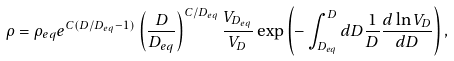Convert formula to latex. <formula><loc_0><loc_0><loc_500><loc_500>\rho = \rho _ { e q } e ^ { C ( D / D _ { e q } - 1 ) } \left ( \frac { D } { D _ { e q } } \right ) ^ { C / D _ { e q } } \frac { V _ { D _ { e q } } } { V _ { D } } \exp \left ( - \int ^ { D } _ { D _ { e q } } d D \frac { 1 } { D } \frac { d \ln V _ { D } } { d D } \right ) ,</formula> 